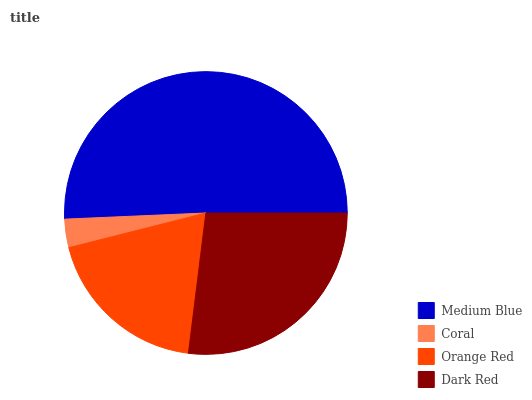Is Coral the minimum?
Answer yes or no. Yes. Is Medium Blue the maximum?
Answer yes or no. Yes. Is Orange Red the minimum?
Answer yes or no. No. Is Orange Red the maximum?
Answer yes or no. No. Is Orange Red greater than Coral?
Answer yes or no. Yes. Is Coral less than Orange Red?
Answer yes or no. Yes. Is Coral greater than Orange Red?
Answer yes or no. No. Is Orange Red less than Coral?
Answer yes or no. No. Is Dark Red the high median?
Answer yes or no. Yes. Is Orange Red the low median?
Answer yes or no. Yes. Is Coral the high median?
Answer yes or no. No. Is Coral the low median?
Answer yes or no. No. 